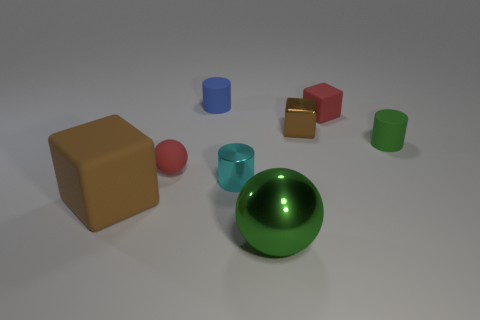There is another thing that is the same color as the big metal object; what size is it?
Provide a short and direct response. Small. The rubber object that is to the left of the tiny green object and on the right side of the tiny metallic block has what shape?
Keep it short and to the point. Cube. Does the small blue object have the same shape as the brown object behind the big brown rubber cube?
Keep it short and to the point. No. There is a small ball; are there any small red matte spheres to the right of it?
Your answer should be very brief. No. There is a small cylinder that is the same color as the metallic sphere; what material is it?
Provide a short and direct response. Rubber. What number of spheres are tiny cyan things or blue matte objects?
Offer a terse response. 0. Is the tiny green matte object the same shape as the large rubber thing?
Your answer should be compact. No. There is a matte block behind the tiny green thing; what is its size?
Your answer should be compact. Small. Is there a thing of the same color as the metallic cube?
Keep it short and to the point. Yes. There is a cylinder in front of the red matte ball; does it have the same size as the big green metallic thing?
Your answer should be very brief. No. 